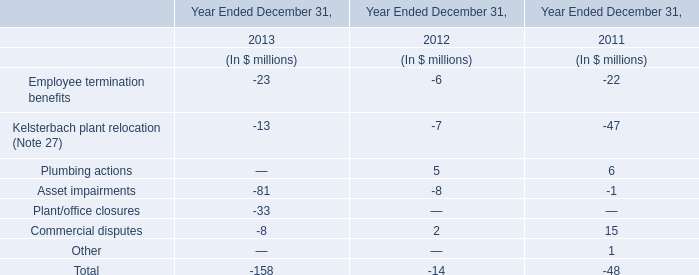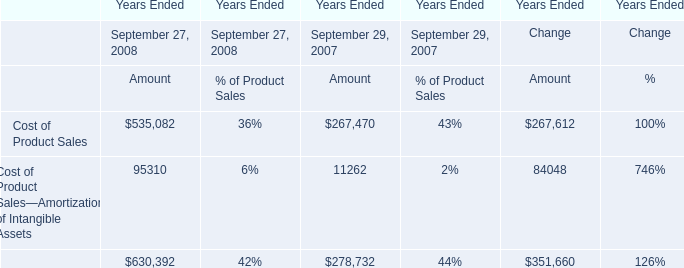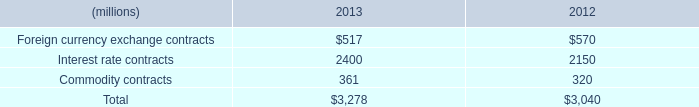what percent of total derivatives are from interest rate contracts in 2013? 
Computations: (2400 / 3278)
Answer: 0.73215. 